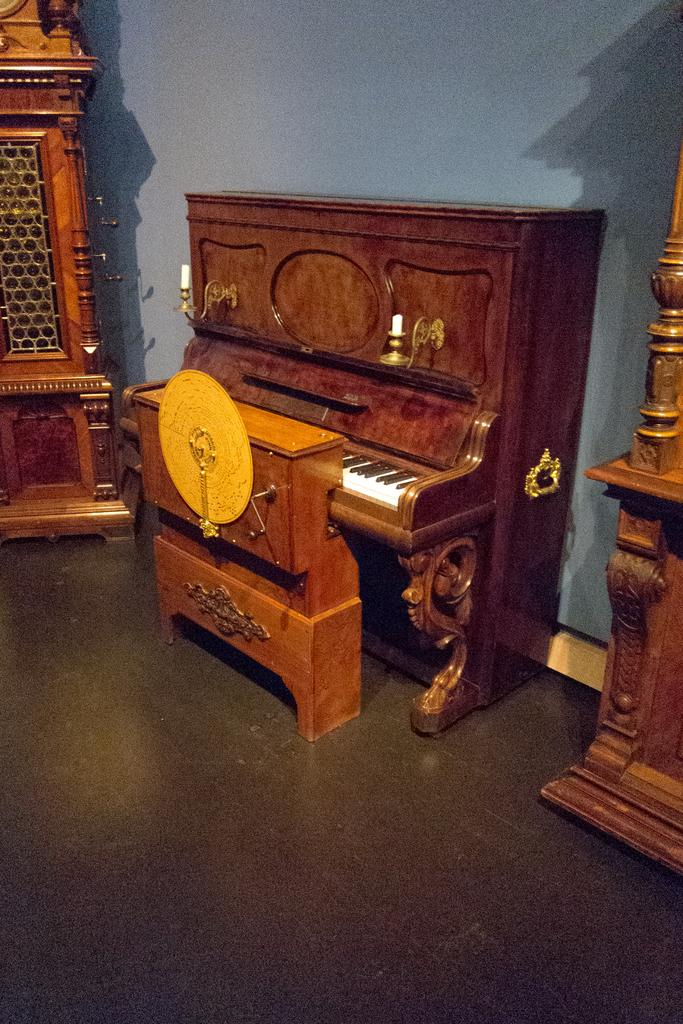What can be seen in the background of the image? There is a wall in the background of the image. What type of furniture is present in the image? There is well-designed furniture in the image. What other items can be seen in the image besides the furniture? There are decorative cupboards and a musical instrument present in the image. What type of surface is visible in the image? The image shows a floor. What is the rate of the crook's performance in the image? There is no crook or performance present in the image; it features a wall, well-designed furniture, decorative cupboards, and a musical instrument. 